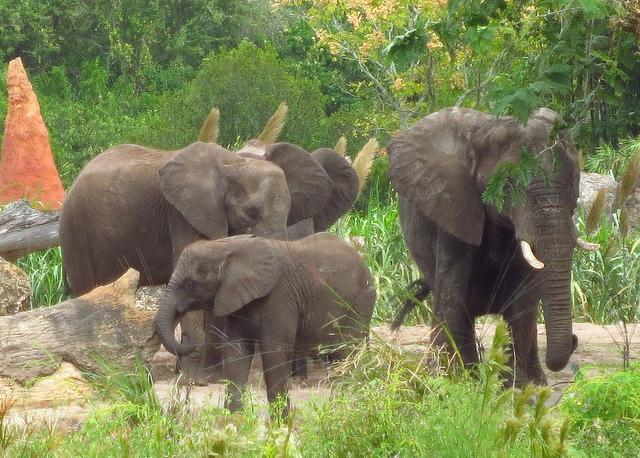How many elephants can be seen?
Give a very brief answer. 4. How many elephants are there?
Give a very brief answer. 3. 